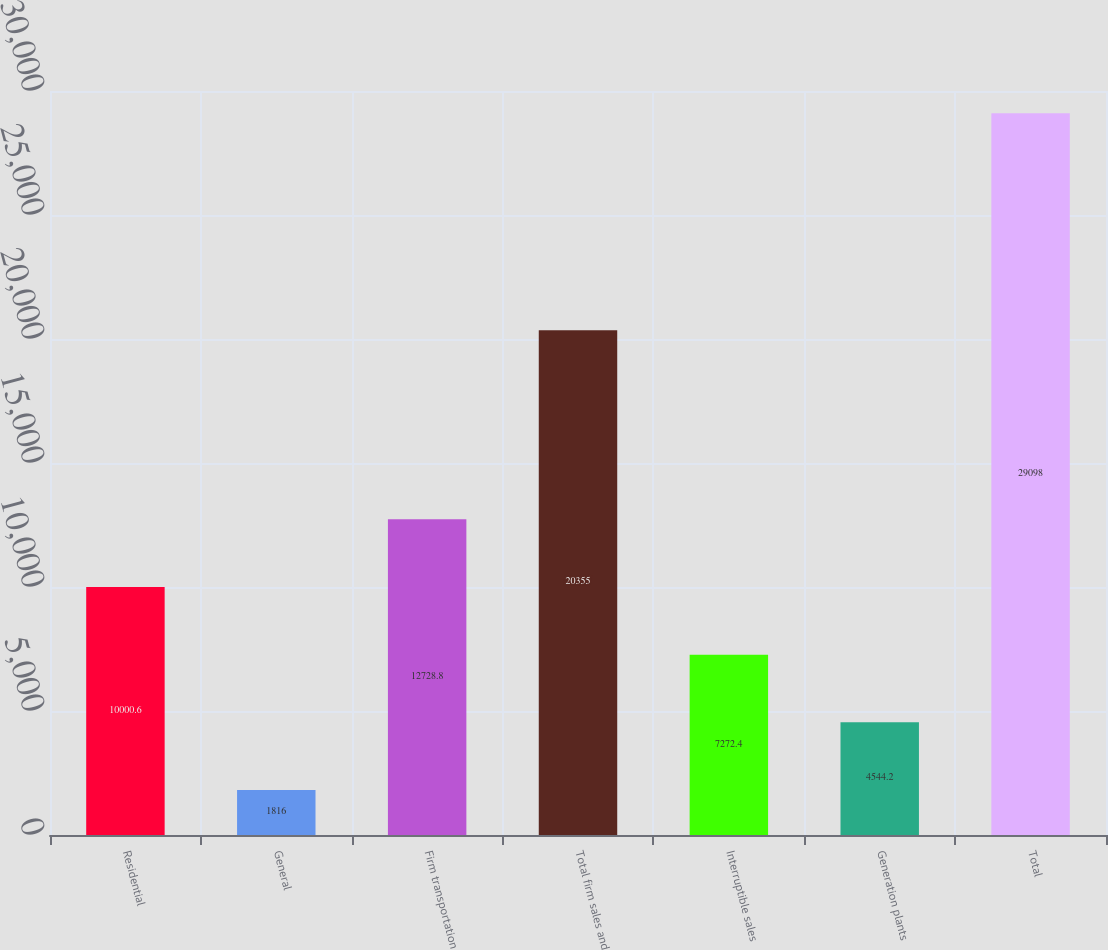<chart> <loc_0><loc_0><loc_500><loc_500><bar_chart><fcel>Residential<fcel>General<fcel>Firm transportation<fcel>Total firm sales and<fcel>Interruptible sales<fcel>Generation plants<fcel>Total<nl><fcel>10000.6<fcel>1816<fcel>12728.8<fcel>20355<fcel>7272.4<fcel>4544.2<fcel>29098<nl></chart> 